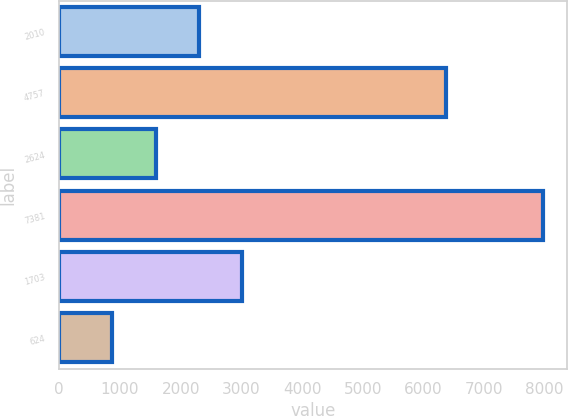Convert chart. <chart><loc_0><loc_0><loc_500><loc_500><bar_chart><fcel>2010<fcel>4757<fcel>2624<fcel>7381<fcel>1703<fcel>624<nl><fcel>2302.1<fcel>6372<fcel>1593<fcel>7965<fcel>3011.2<fcel>874<nl></chart> 